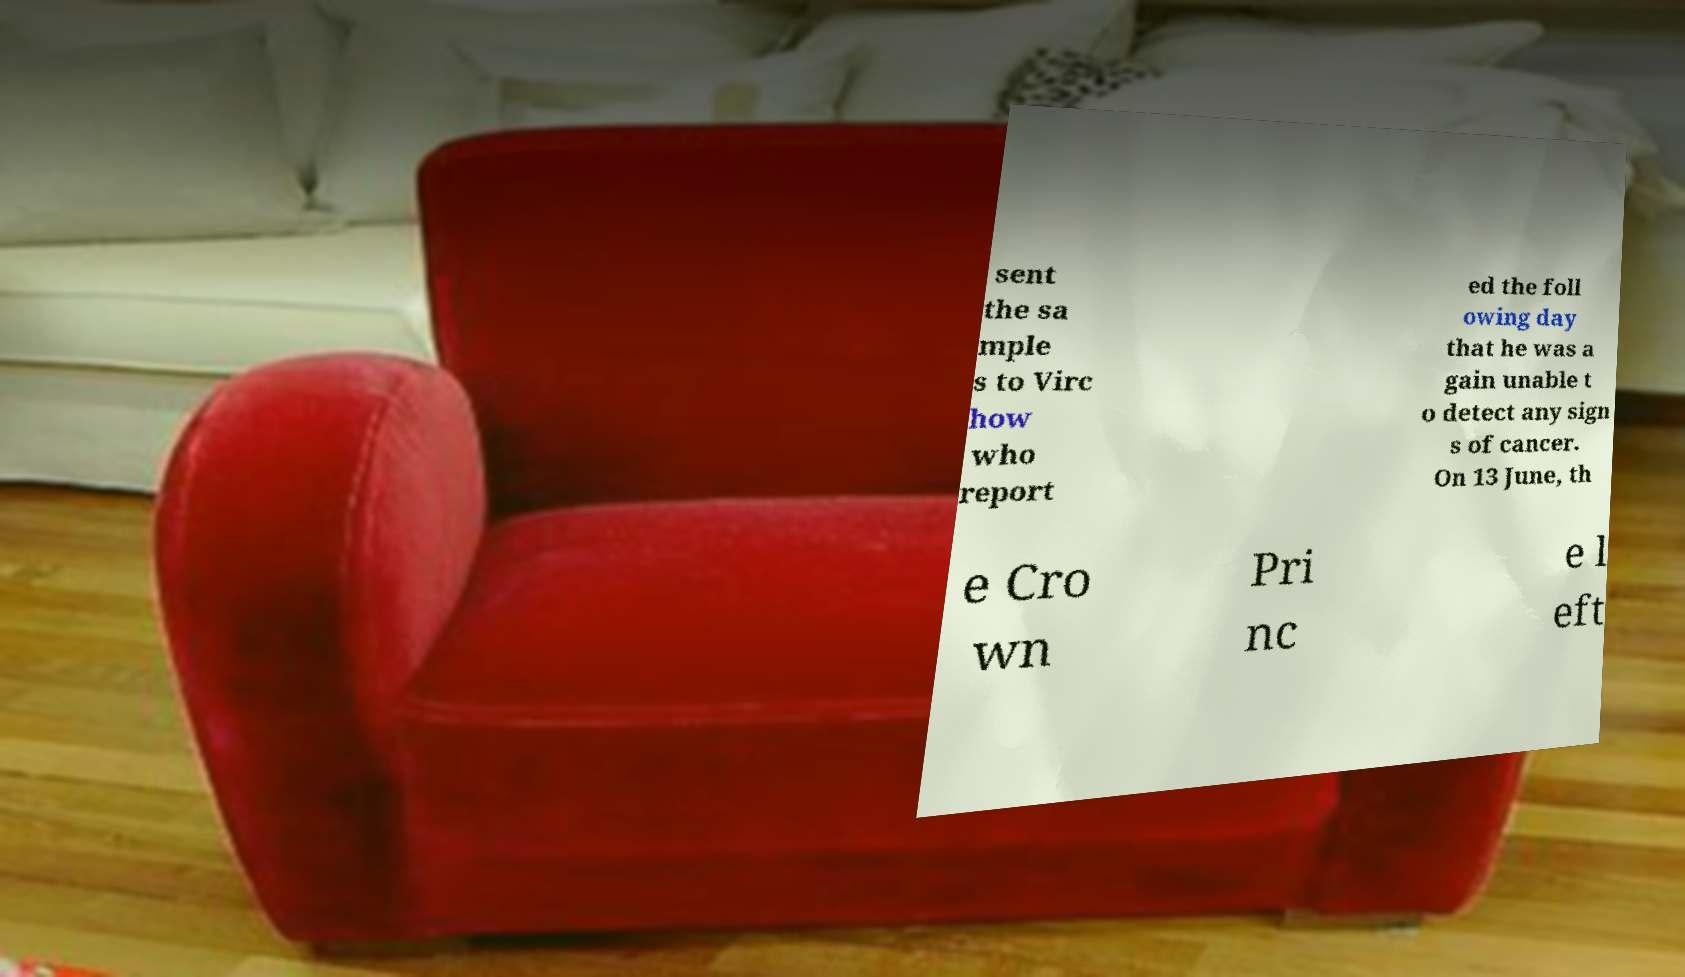Can you read and provide the text displayed in the image?This photo seems to have some interesting text. Can you extract and type it out for me? sent the sa mple s to Virc how who report ed the foll owing day that he was a gain unable t o detect any sign s of cancer. On 13 June, th e Cro wn Pri nc e l eft 